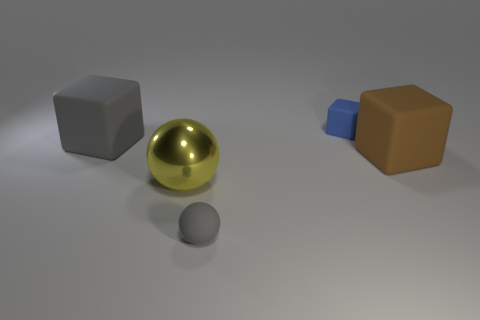Add 1 rubber spheres. How many objects exist? 6 Subtract all cubes. How many objects are left? 2 Add 5 brown matte objects. How many brown matte objects are left? 6 Add 4 big things. How many big things exist? 7 Subtract 0 blue cylinders. How many objects are left? 5 Subtract all shiny objects. Subtract all blue rubber objects. How many objects are left? 3 